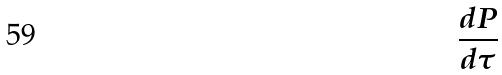<formula> <loc_0><loc_0><loc_500><loc_500>\frac { d P } { d \tau }</formula> 